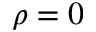Convert formula to latex. <formula><loc_0><loc_0><loc_500><loc_500>\rho = 0</formula> 